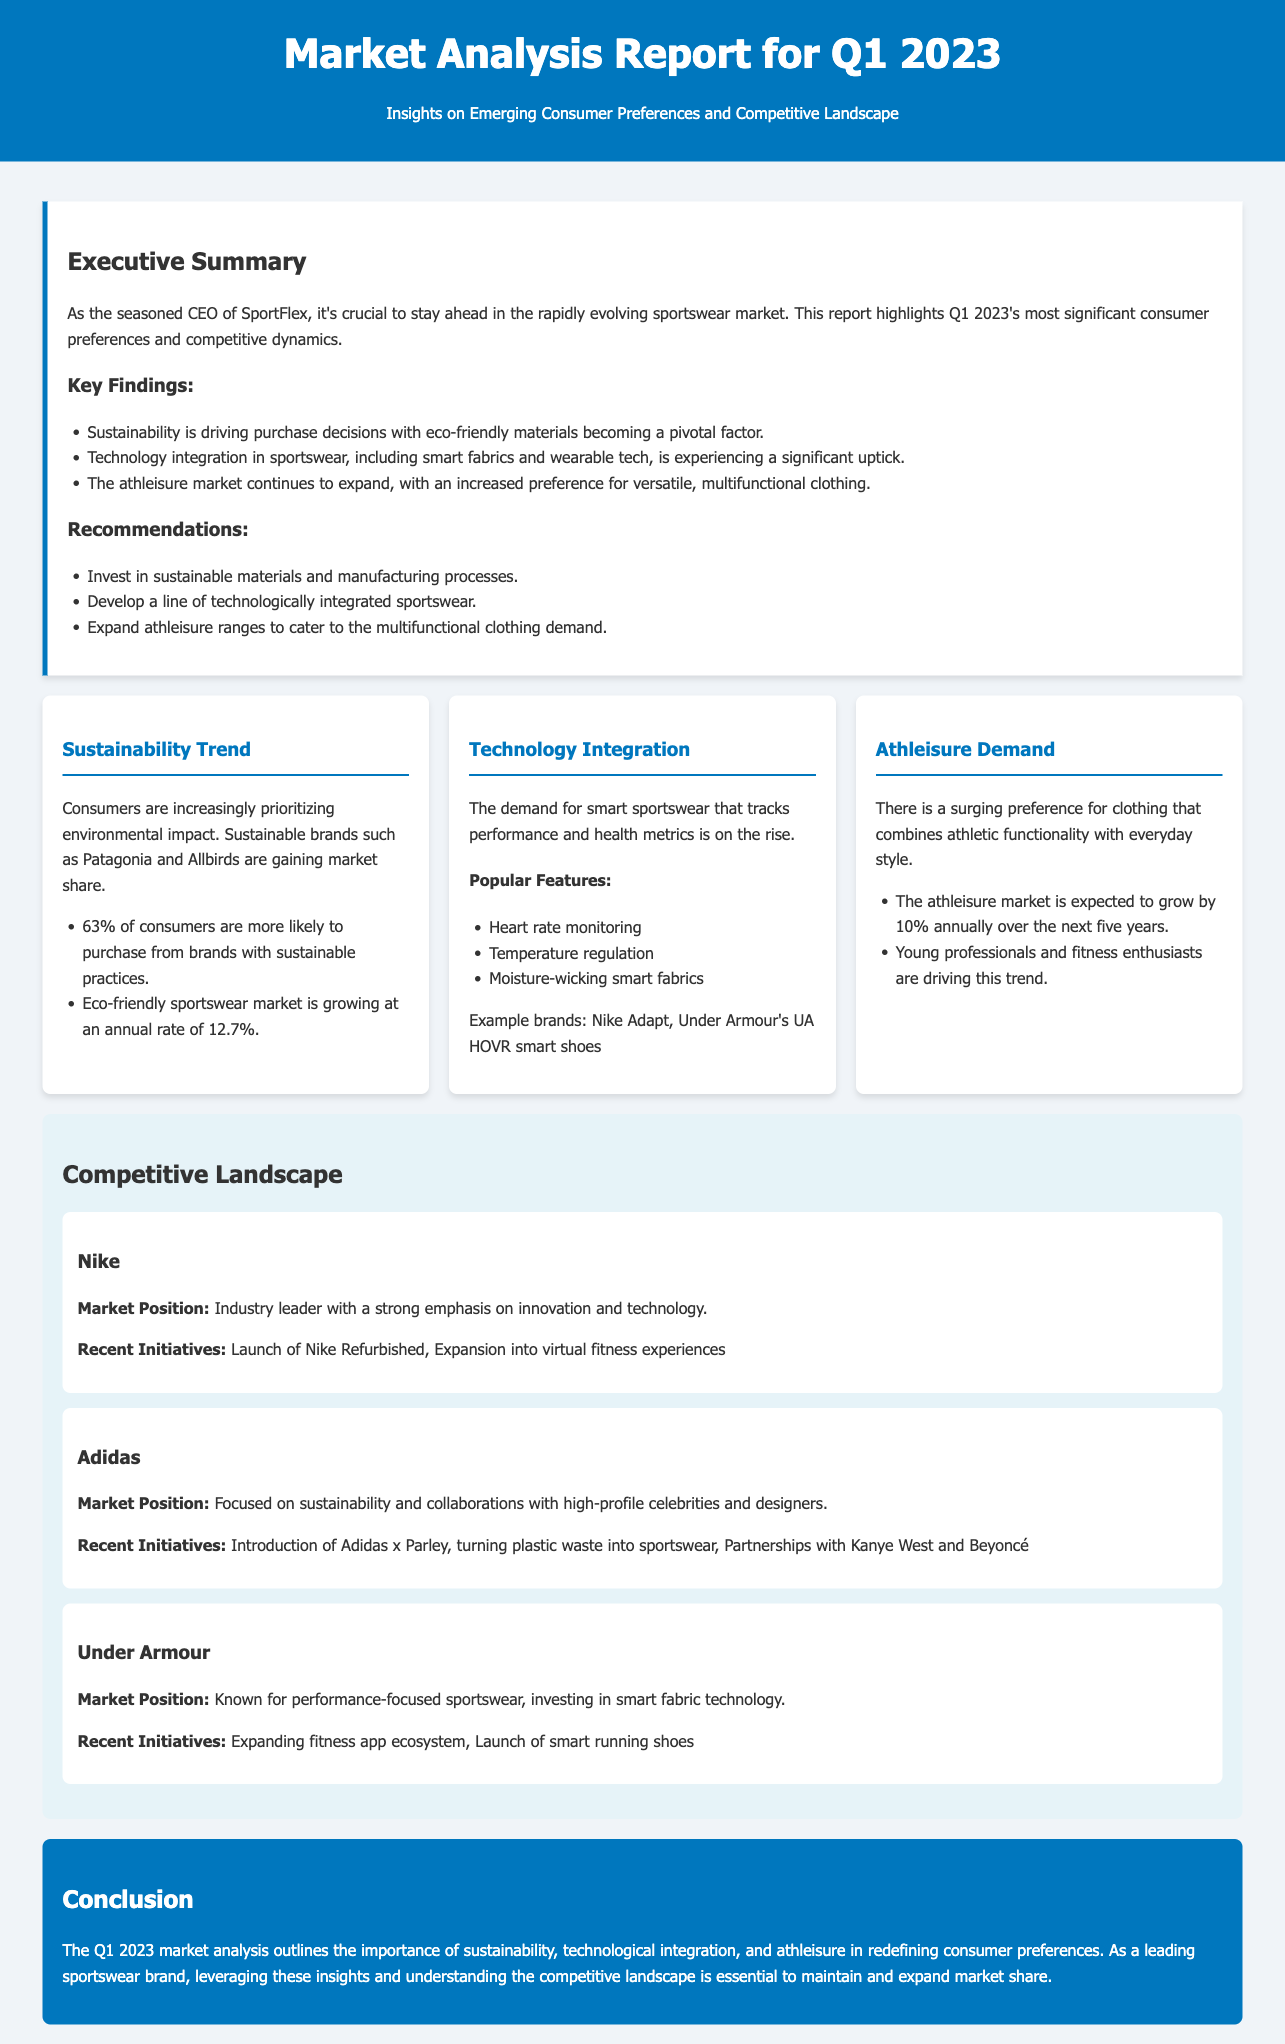What is the expected growth rate of the eco-friendly sportswear market? The document indicates the eco-friendly sportswear market is growing at an annual rate of 12.7%.
Answer: 12.7% What percentage of consumers prefer brands with sustainable practices? The document states that 63% of consumers are more likely to purchase from brands with sustainable practices.
Answer: 63% What are two popular features of smart sportswear mentioned? The document lists heart rate monitoring and temperature regulation as popular features.
Answer: Heart rate monitoring, temperature regulation Which demographic is driving the athleisure trend? The document notes that young professionals and fitness enthusiasts are driving the athleisure trend.
Answer: Young professionals and fitness enthusiasts Who leads the market in the sportswear industry? The document describes Nike as the industry leader with a strong emphasis on innovation and technology.
Answer: Nike What recent initiative is associated with Adidas? The document mentions the introduction of Adidas x Parley, turning plastic waste into sportswear, as a recent initiative.
Answer: Adidas x Parley What is the market growth expectation for athleisure clothing over the next five years? The document states that the athleisure market is expected to grow by 10% annually over the next five years.
Answer: 10% What focus is Under Armour known for? The document highlights that Under Armour is known for performance-focused sportswear.
Answer: Performance-focused sportswear What does the Executive Summary emphasize as crucial for staying ahead in the sportswear market? It emphasizes the importance of staying ahead in the rapidly evolving sportswear market through understanding consumer preferences and competitive dynamics.
Answer: Understanding consumer preferences and competitive dynamics 